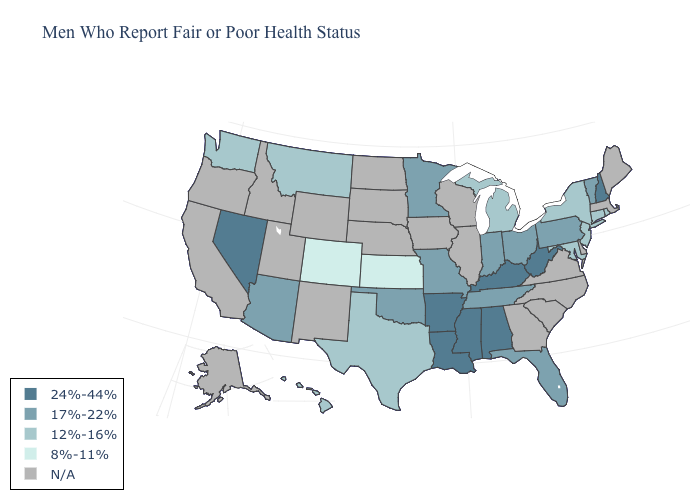What is the value of Utah?
Short answer required. N/A. Name the states that have a value in the range 8%-11%?
Write a very short answer. Colorado, Kansas. Among the states that border Alabama , does Mississippi have the highest value?
Give a very brief answer. Yes. What is the value of Tennessee?
Be succinct. 17%-22%. Does Oklahoma have the lowest value in the South?
Give a very brief answer. No. Does the map have missing data?
Be succinct. Yes. Name the states that have a value in the range 24%-44%?
Keep it brief. Alabama, Arkansas, Kentucky, Louisiana, Mississippi, Nevada, New Hampshire, West Virginia. Among the states that border Arkansas , which have the lowest value?
Quick response, please. Texas. Among the states that border Arkansas , does Texas have the lowest value?
Keep it brief. Yes. Which states have the lowest value in the Northeast?
Concise answer only. Connecticut, New Jersey, New York, Rhode Island. What is the value of West Virginia?
Answer briefly. 24%-44%. Name the states that have a value in the range 17%-22%?
Keep it brief. Arizona, Florida, Indiana, Minnesota, Missouri, Ohio, Oklahoma, Pennsylvania, Tennessee, Vermont. 